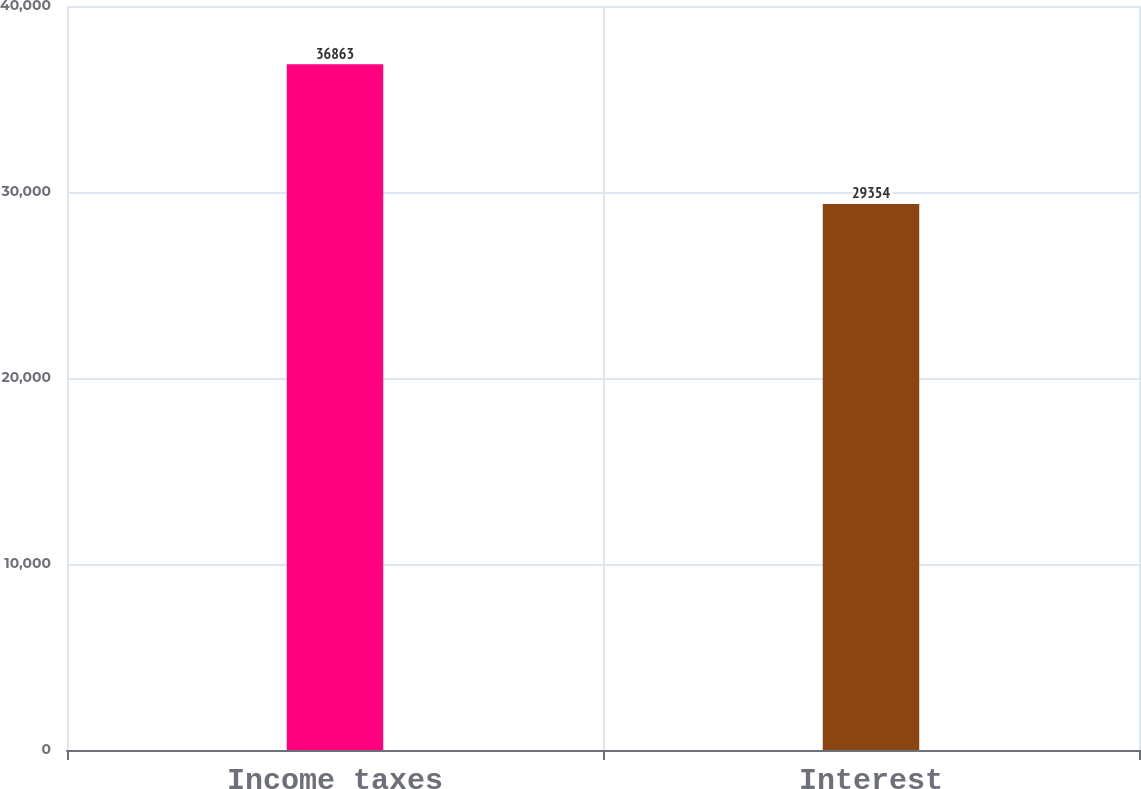Convert chart to OTSL. <chart><loc_0><loc_0><loc_500><loc_500><bar_chart><fcel>Income taxes<fcel>Interest<nl><fcel>36863<fcel>29354<nl></chart> 